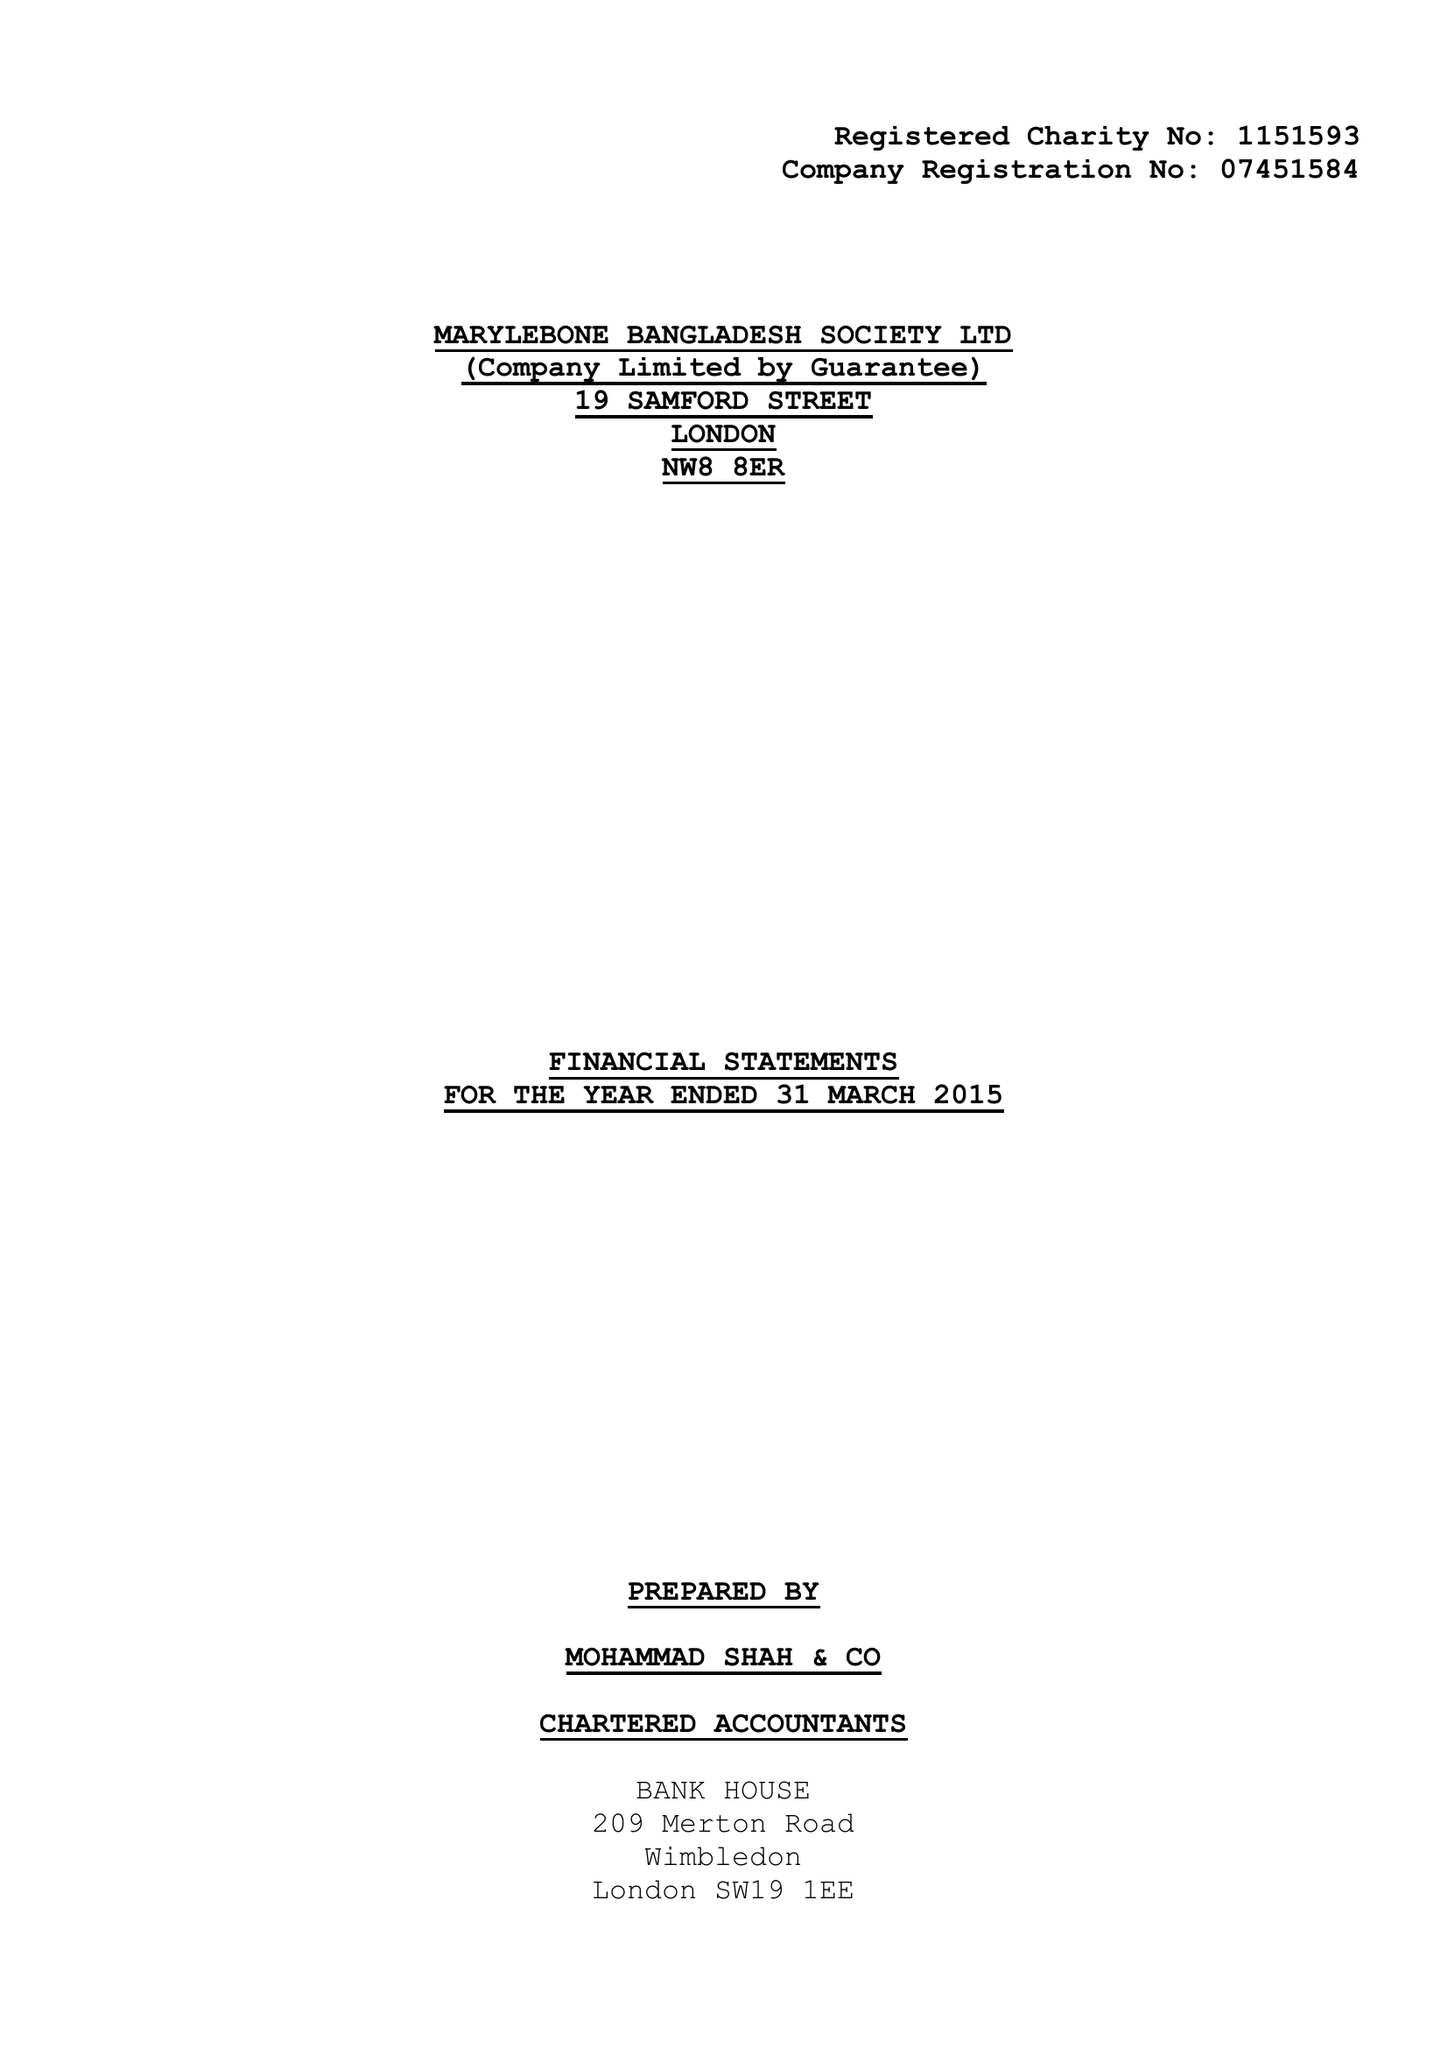What is the value for the report_date?
Answer the question using a single word or phrase. 2015-03-31 